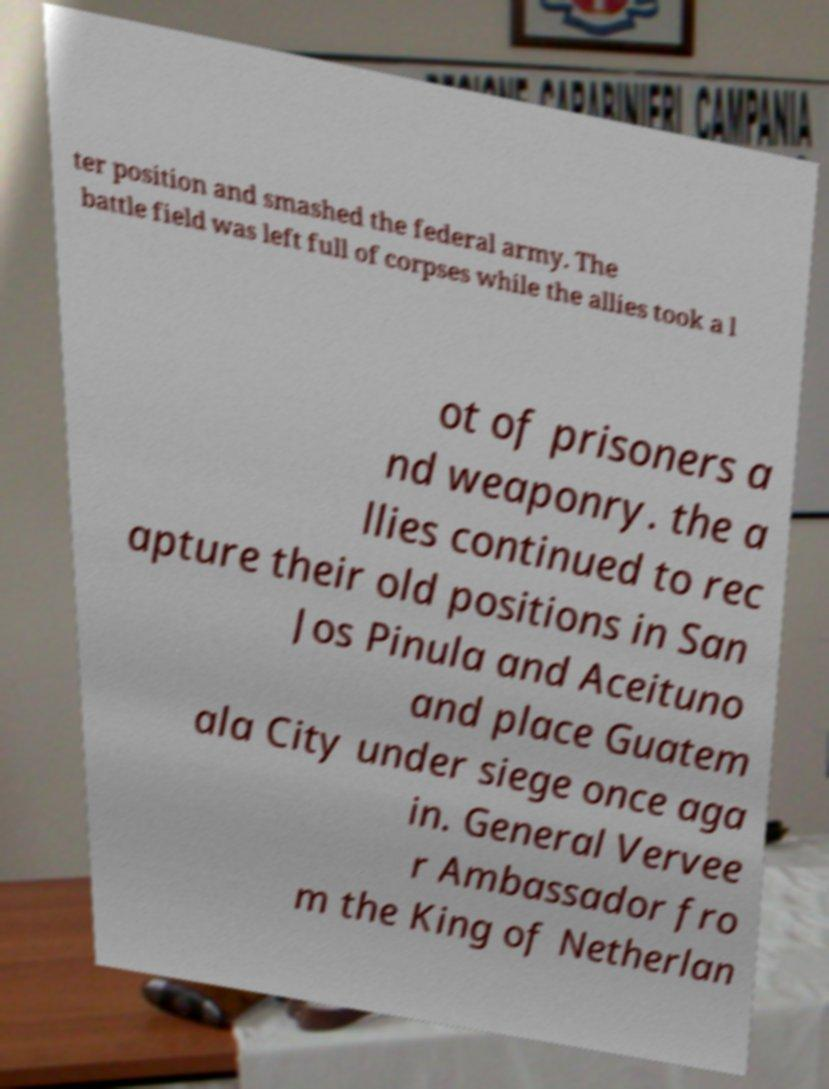For documentation purposes, I need the text within this image transcribed. Could you provide that? ter position and smashed the federal army. The battle field was left full of corpses while the allies took a l ot of prisoners a nd weaponry. the a llies continued to rec apture their old positions in San Jos Pinula and Aceituno and place Guatem ala City under siege once aga in. General Vervee r Ambassador fro m the King of Netherlan 